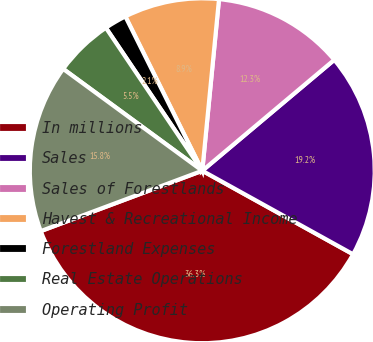Convert chart to OTSL. <chart><loc_0><loc_0><loc_500><loc_500><pie_chart><fcel>In millions<fcel>Sales<fcel>Sales of Forestlands<fcel>Havest & Recreational Income<fcel>Forestland Expenses<fcel>Real Estate Operations<fcel>Operating Profit<nl><fcel>36.26%<fcel>19.17%<fcel>12.33%<fcel>8.91%<fcel>2.08%<fcel>5.5%<fcel>15.75%<nl></chart> 